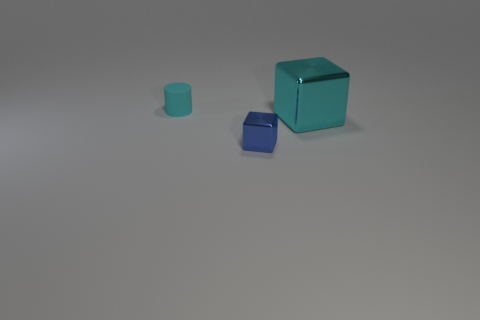Add 3 small blue shiny cubes. How many objects exist? 6 Subtract all blue blocks. How many blocks are left? 1 Subtract all blocks. How many objects are left? 1 Subtract 1 cylinders. How many cylinders are left? 0 Subtract 0 brown balls. How many objects are left? 3 Subtract all gray cylinders. Subtract all cyan blocks. How many cylinders are left? 1 Subtract all rubber cylinders. Subtract all small blue things. How many objects are left? 1 Add 1 tiny objects. How many tiny objects are left? 3 Add 2 big green balls. How many big green balls exist? 2 